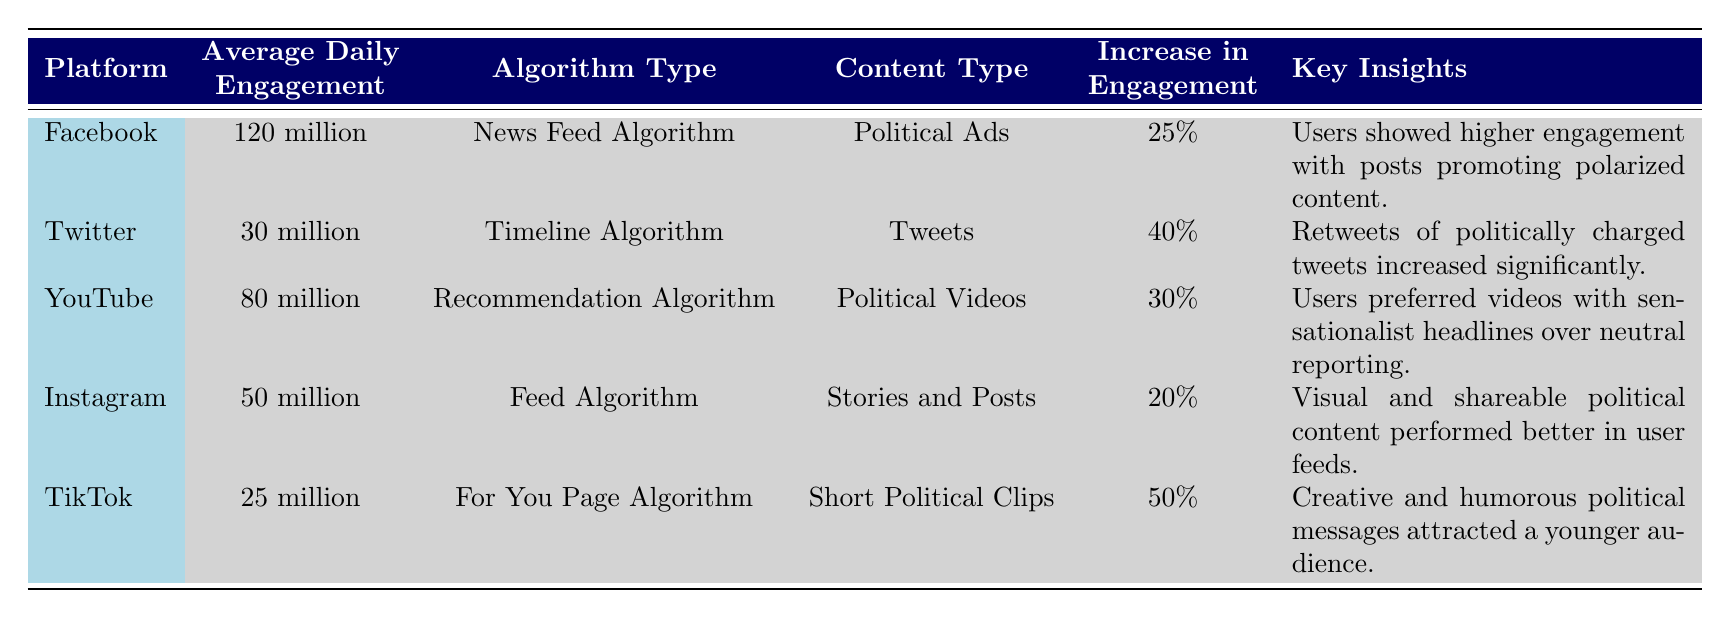What is the average daily engagement on Facebook? According to the table under the "Average Daily Engagement" column for Facebook, the value listed is "120 million." Therefore, the average daily engagement on Facebook is directly taken from the table.
Answer: 120 million Which platform had the highest increase in engagement? We compare the "Increase in Engagement" percentages across all platforms. TikTok shows a 50% increase, which is greater than the other platforms: Facebook (25%), Twitter (40%), YouTube (30%), and Instagram (20%). Hence, TikTok had the highest increase.
Answer: TikTok What type of content resulted in a 40% increase in engagement? Referring to the "Increase in Engagement" column for a 40% increase, the corresponding platform is Twitter, where the "Content Type" is "Tweets." This matches the requirement.
Answer: Tweets Did Instagram have a higher average daily engagement than TikTok? By reviewing the "Average Daily Engagement" values, Instagram has 50 million while TikTok has 25 million. Since 50 million is greater than 25 million, this statement is true.
Answer: Yes What is the total average daily engagement of all platforms listed? We sum the average daily engagement values: Facebook (120 million) + Twitter (30 million) + YouTube (80 million) + Instagram (50 million) + TikTok (25 million) = 305 million. Therefore, the total average daily engagement is 305 million.
Answer: 305 million Which platform's algorithm is associated with political videos? The "Content Type" associated with the recommendation algorithm is noted as "Political Videos," which corresponds to YouTube in the "Platform" column. This is a direct reference to the information in the table.
Answer: YouTube Are users engaging more with politically charged tweets compared to other types of tweets? The key insight for Twitter indicates that "Retweets of politically charged tweets increased significantly," implying that engagement is indeed higher for this type of content.
Answer: Yes What was the key insight regarding user preference for political content on YouTube? The table states that users preferred "videos with sensationalist headlines over neutral reporting," giving a clear summary of user behavior on YouTube regarding political content.
Answer: Sensationalist headlines preferred Which platform had the lowest average daily engagement? Upon examining the "Average Daily Engagement" values, TikTok has the lowest figure with 25 million, which is less than the others: Facebook (120 million), Twitter (30 million), YouTube (80 million), and Instagram (50 million).
Answer: TikTok 